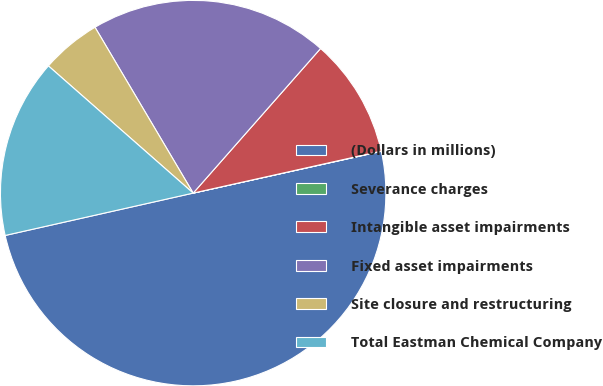Convert chart to OTSL. <chart><loc_0><loc_0><loc_500><loc_500><pie_chart><fcel>(Dollars in millions)<fcel>Severance charges<fcel>Intangible asset impairments<fcel>Fixed asset impairments<fcel>Site closure and restructuring<fcel>Total Eastman Chemical Company<nl><fcel>49.95%<fcel>0.02%<fcel>10.01%<fcel>20.0%<fcel>5.02%<fcel>15.0%<nl></chart> 